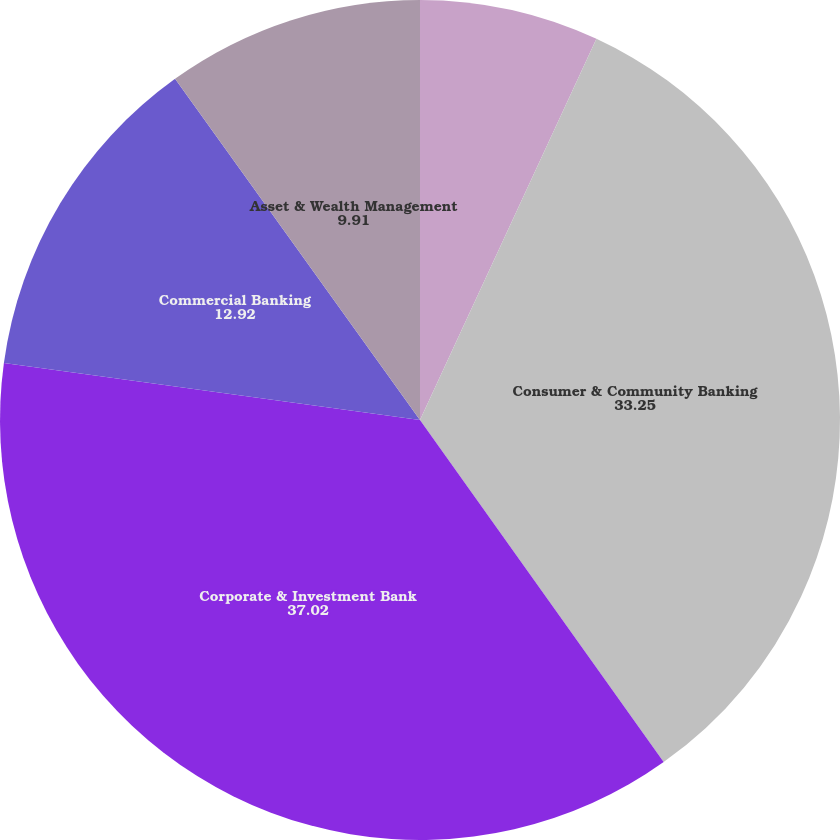Convert chart to OTSL. <chart><loc_0><loc_0><loc_500><loc_500><pie_chart><fcel>(in millions except ratios)<fcel>Consumer & Community Banking<fcel>Corporate & Investment Bank<fcel>Commercial Banking<fcel>Asset & Wealth Management<nl><fcel>6.9%<fcel>33.25%<fcel>37.02%<fcel>12.92%<fcel>9.91%<nl></chart> 